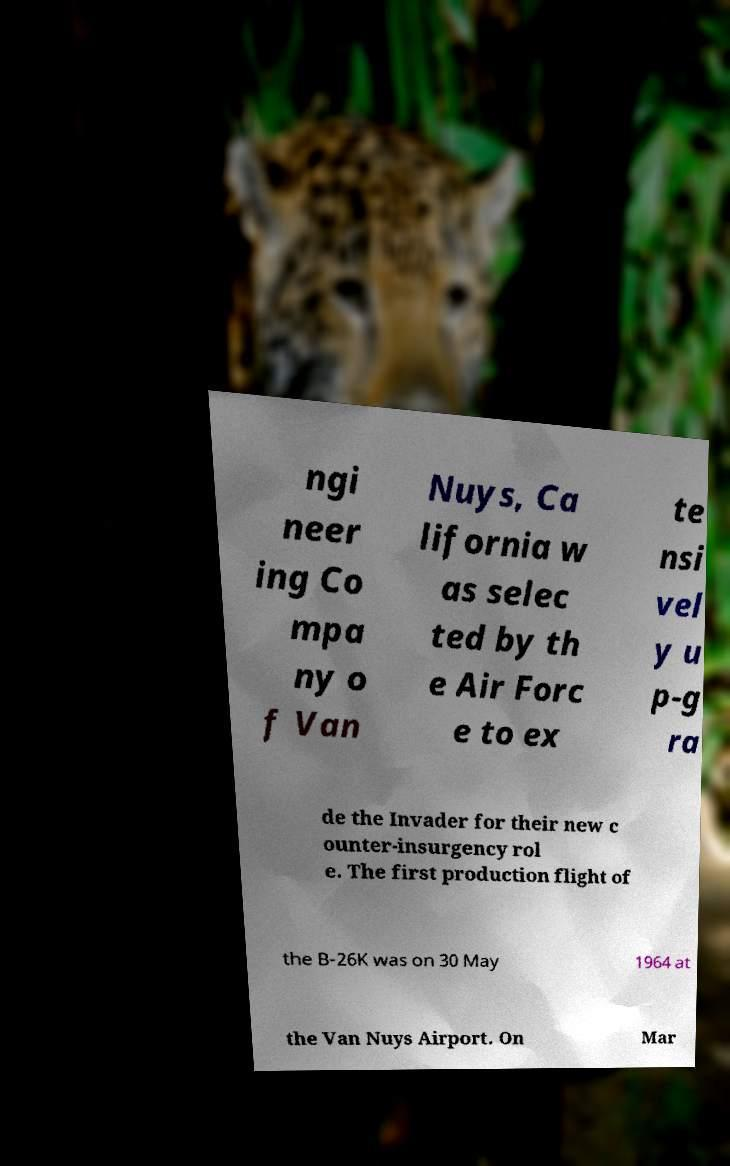Could you assist in decoding the text presented in this image and type it out clearly? ngi neer ing Co mpa ny o f Van Nuys, Ca lifornia w as selec ted by th e Air Forc e to ex te nsi vel y u p-g ra de the Invader for their new c ounter-insurgency rol e. The first production flight of the B-26K was on 30 May 1964 at the Van Nuys Airport. On Mar 